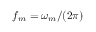Convert formula to latex. <formula><loc_0><loc_0><loc_500><loc_500>f _ { m } = \omega _ { m } / ( 2 \pi )</formula> 